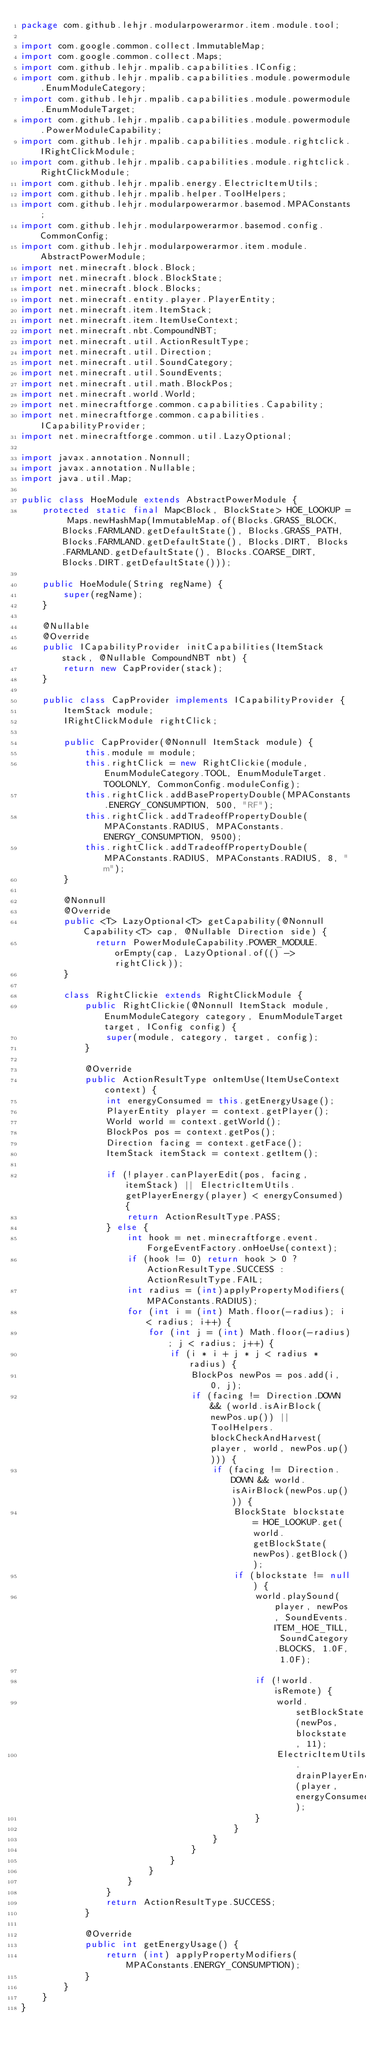<code> <loc_0><loc_0><loc_500><loc_500><_Java_>package com.github.lehjr.modularpowerarmor.item.module.tool;

import com.google.common.collect.ImmutableMap;
import com.google.common.collect.Maps;
import com.github.lehjr.mpalib.capabilities.IConfig;
import com.github.lehjr.mpalib.capabilities.module.powermodule.EnumModuleCategory;
import com.github.lehjr.mpalib.capabilities.module.powermodule.EnumModuleTarget;
import com.github.lehjr.mpalib.capabilities.module.powermodule.PowerModuleCapability;
import com.github.lehjr.mpalib.capabilities.module.rightclick.IRightClickModule;
import com.github.lehjr.mpalib.capabilities.module.rightclick.RightClickModule;
import com.github.lehjr.mpalib.energy.ElectricItemUtils;
import com.github.lehjr.mpalib.helper.ToolHelpers;
import com.github.lehjr.modularpowerarmor.basemod.MPAConstants;
import com.github.lehjr.modularpowerarmor.basemod.config.CommonConfig;
import com.github.lehjr.modularpowerarmor.item.module.AbstractPowerModule;
import net.minecraft.block.Block;
import net.minecraft.block.BlockState;
import net.minecraft.block.Blocks;
import net.minecraft.entity.player.PlayerEntity;
import net.minecraft.item.ItemStack;
import net.minecraft.item.ItemUseContext;
import net.minecraft.nbt.CompoundNBT;
import net.minecraft.util.ActionResultType;
import net.minecraft.util.Direction;
import net.minecraft.util.SoundCategory;
import net.minecraft.util.SoundEvents;
import net.minecraft.util.math.BlockPos;
import net.minecraft.world.World;
import net.minecraftforge.common.capabilities.Capability;
import net.minecraftforge.common.capabilities.ICapabilityProvider;
import net.minecraftforge.common.util.LazyOptional;

import javax.annotation.Nonnull;
import javax.annotation.Nullable;
import java.util.Map;

public class HoeModule extends AbstractPowerModule {
    protected static final Map<Block, BlockState> HOE_LOOKUP = Maps.newHashMap(ImmutableMap.of(Blocks.GRASS_BLOCK, Blocks.FARMLAND.getDefaultState(), Blocks.GRASS_PATH, Blocks.FARMLAND.getDefaultState(), Blocks.DIRT, Blocks.FARMLAND.getDefaultState(), Blocks.COARSE_DIRT, Blocks.DIRT.getDefaultState()));

    public HoeModule(String regName) {
        super(regName);
    }

    @Nullable
    @Override
    public ICapabilityProvider initCapabilities(ItemStack stack, @Nullable CompoundNBT nbt) {
        return new CapProvider(stack);
    }

    public class CapProvider implements ICapabilityProvider {
        ItemStack module;
        IRightClickModule rightClick;

        public CapProvider(@Nonnull ItemStack module) {
            this.module = module;
            this.rightClick = new RightClickie(module, EnumModuleCategory.TOOL, EnumModuleTarget.TOOLONLY, CommonConfig.moduleConfig);
            this.rightClick.addBasePropertyDouble(MPAConstants.ENERGY_CONSUMPTION, 500, "RF");
            this.rightClick.addTradeoffPropertyDouble(MPAConstants.RADIUS, MPAConstants.ENERGY_CONSUMPTION, 9500);
            this.rightClick.addTradeoffPropertyDouble(MPAConstants.RADIUS, MPAConstants.RADIUS, 8, "m");
        }

        @Nonnull
        @Override
        public <T> LazyOptional<T> getCapability(@Nonnull Capability<T> cap, @Nullable Direction side) {
              return PowerModuleCapability.POWER_MODULE.orEmpty(cap, LazyOptional.of(() -> rightClick));
        }

        class RightClickie extends RightClickModule {
            public RightClickie(@Nonnull ItemStack module, EnumModuleCategory category, EnumModuleTarget target, IConfig config) {
                super(module, category, target, config);
            }

            @Override
            public ActionResultType onItemUse(ItemUseContext context) {
                int energyConsumed = this.getEnergyUsage();
                PlayerEntity player = context.getPlayer();
                World world = context.getWorld();
                BlockPos pos = context.getPos();
                Direction facing = context.getFace();
                ItemStack itemStack = context.getItem();

                if (!player.canPlayerEdit(pos, facing, itemStack) || ElectricItemUtils.getPlayerEnergy(player) < energyConsumed) {
                    return ActionResultType.PASS;
                } else {
                    int hook = net.minecraftforge.event.ForgeEventFactory.onHoeUse(context);
                    if (hook != 0) return hook > 0 ? ActionResultType.SUCCESS : ActionResultType.FAIL;
                    int radius = (int)applyPropertyModifiers(MPAConstants.RADIUS);
                    for (int i = (int) Math.floor(-radius); i < radius; i++) {
                        for (int j = (int) Math.floor(-radius); j < radius; j++) {
                            if (i * i + j * j < radius * radius) {
                                BlockPos newPos = pos.add(i, 0, j);
                                if (facing != Direction.DOWN && (world.isAirBlock(newPos.up()) || ToolHelpers.blockCheckAndHarvest(player, world, newPos.up()))) {
                                    if (facing != Direction.DOWN && world.isAirBlock(newPos.up())) {
                                        BlockState blockstate = HOE_LOOKUP.get(world.getBlockState(newPos).getBlock());
                                        if (blockstate != null) {
                                            world.playSound(player, newPos, SoundEvents.ITEM_HOE_TILL, SoundCategory.BLOCKS, 1.0F, 1.0F);

                                            if (!world.isRemote) {
                                                world.setBlockState(newPos, blockstate, 11);
                                                ElectricItemUtils.drainPlayerEnergy(player, energyConsumed);
                                            }
                                        }
                                    }
                                }
                            }
                        }
                    }
                }
                return ActionResultType.SUCCESS;
            }

            @Override
            public int getEnergyUsage() {
                return (int) applyPropertyModifiers(MPAConstants.ENERGY_CONSUMPTION);
            }
        }
    }
}</code> 